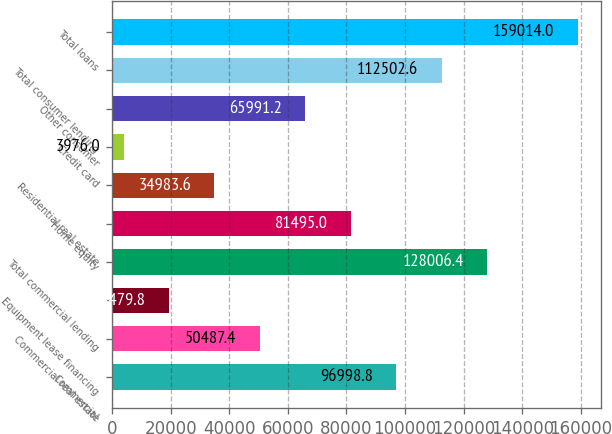Convert chart to OTSL. <chart><loc_0><loc_0><loc_500><loc_500><bar_chart><fcel>Commercial<fcel>Commercial real estate<fcel>Equipment lease financing<fcel>Total commercial lending<fcel>Home equity<fcel>Residential real estate<fcel>Credit card<fcel>Other consumer<fcel>Total consumer lending<fcel>Total loans<nl><fcel>96998.8<fcel>50487.4<fcel>19479.8<fcel>128006<fcel>81495<fcel>34983.6<fcel>3976<fcel>65991.2<fcel>112503<fcel>159014<nl></chart> 